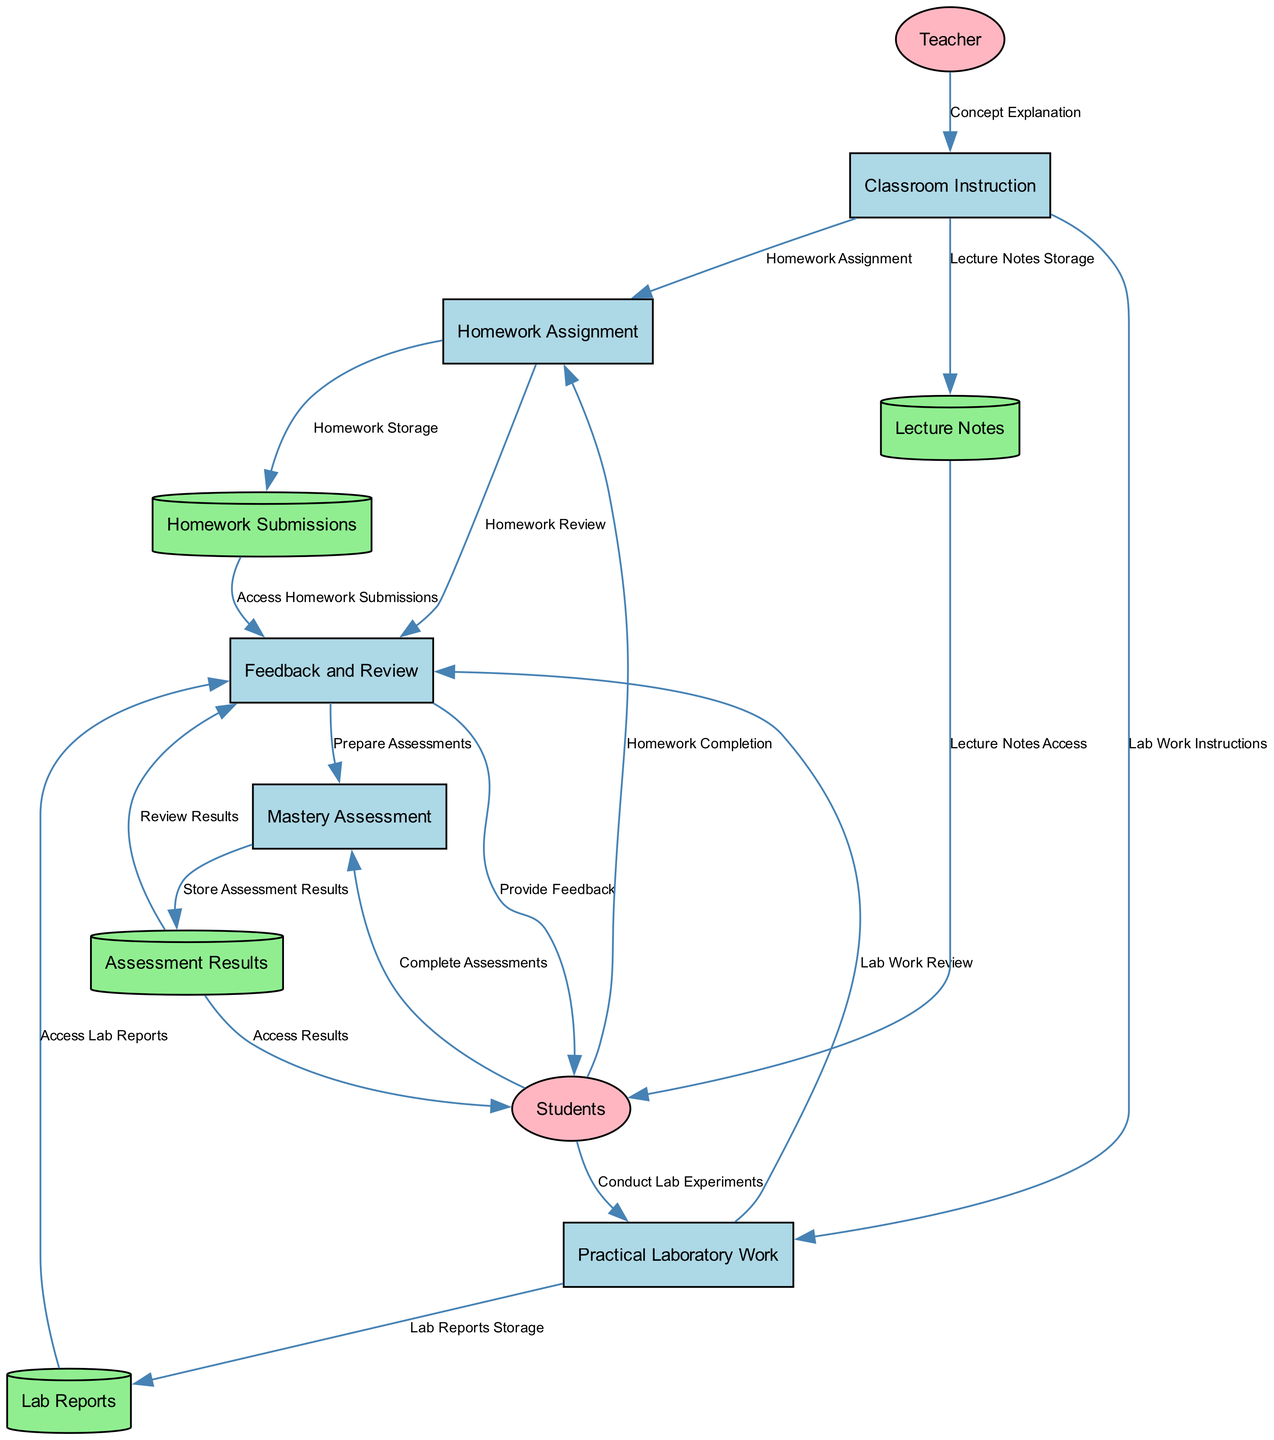What is the first process in the diagram? The diagram starts with "Classroom Instruction" as the initial process where the teacher explains the complex chemistry concept. This is the first node listed under Processes.
Answer: Classroom Instruction How many Data Stores are present in the diagram? The diagram lists four Data Stores: Lecture Notes, Homework Submissions, Lab Reports, and Assessment Results. Counting these gives a total of four Data Stores.
Answer: 4 What entity provides feedback in the process? The "Teacher" is the external entity responsible for providing feedback on homework and lab reports, as indicated in the flows leading to and from the Feedback and Review process.
Answer: Teacher Which process follows "Practical Laboratory Work"? After "Practical Laboratory Work," the next process is "Feedback and Review," where teacher feedback is provided on the lab work completed by the students. This is indicated by the directed flow from the Practical Laboratory Work process to the Feedback and Review process.
Answer: Feedback and Review What is stored after the Mastery Assessment? Following the Mastery Assessment process, the results and scores are stored in the "Assessment Results" Data Store as indicated by the flow from the Mastery Assessment process.
Answer: Assessment Results Which Data Store accesses the Lab Reports? The "Feedback and Review" process accesses the "Lab Reports" Data Store to review the outcomes of the laboratory work performed by students, as shown in the flow from the Lab Reports Data Store to the Feedback and Review process.
Answer: Lab Reports How many processes are there in total? The diagram consists of five processes: Classroom Instruction, Homework Assignment, Practical Laboratory Work, Feedback and Review, and Mastery Assessment. Adding these gives a total of five processes.
Answer: 5 What flow connects Students to Homework Assignment? The connection between Students and Homework Assignment is represented by the flow named "Homework Completion," indicating that students complete and submit their homework assignments after they are assigned.
Answer: Homework Completion Which process comes after Feedback and Review? After the Feedback and Review process, the next step is "Mastery Assessment," where students demonstrate their understanding of the complex chemistry concept through assessments. This flow illustrates the progression to mastering the content.
Answer: Mastery Assessment 